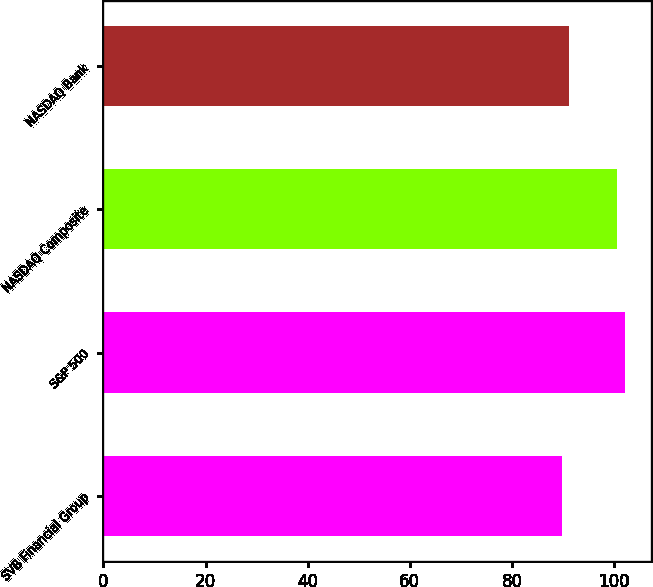Convert chart to OTSL. <chart><loc_0><loc_0><loc_500><loc_500><bar_chart><fcel>SVB Financial Group<fcel>S&P 500<fcel>NASDAQ Composite<fcel>NASDAQ Bank<nl><fcel>89.9<fcel>102.11<fcel>100.53<fcel>91.12<nl></chart> 